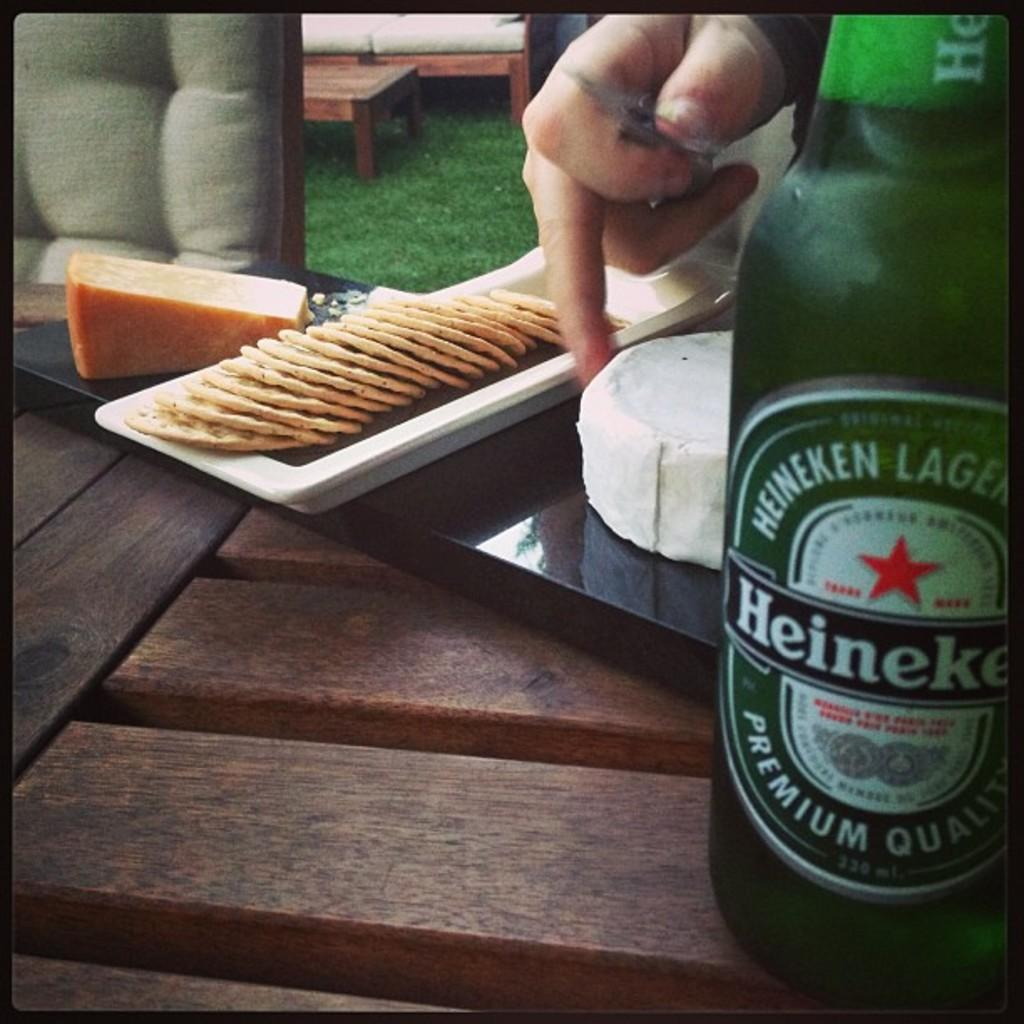Provide a one-sentence caption for the provided image. A green bottle of Heineken beer sits on a wooden bench. 